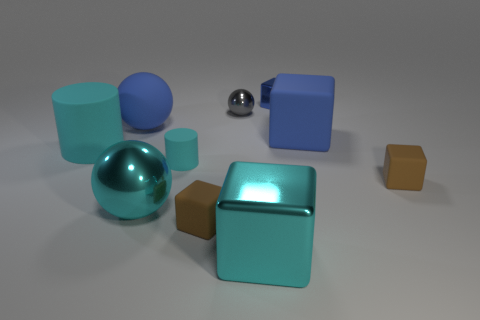Is the number of big blue matte blocks greater than the number of large yellow cylinders?
Give a very brief answer. Yes. What is the small blue object made of?
Offer a terse response. Metal. There is a cyan shiny thing that is on the right side of the gray sphere; does it have the same size as the small gray thing?
Your answer should be very brief. No. What is the size of the matte cube that is behind the tiny cylinder?
Make the answer very short. Large. Are there any other things that have the same material as the tiny gray thing?
Offer a very short reply. Yes. How many small blue blocks are there?
Provide a short and direct response. 1. Does the big cylinder have the same color as the small sphere?
Offer a very short reply. No. What color is the object that is right of the large cylinder and on the left side of the big metal sphere?
Provide a short and direct response. Blue. Are there any small balls right of the cyan metal block?
Your answer should be very brief. No. How many cyan metallic blocks are behind the small rubber block right of the blue shiny object?
Provide a short and direct response. 0. 